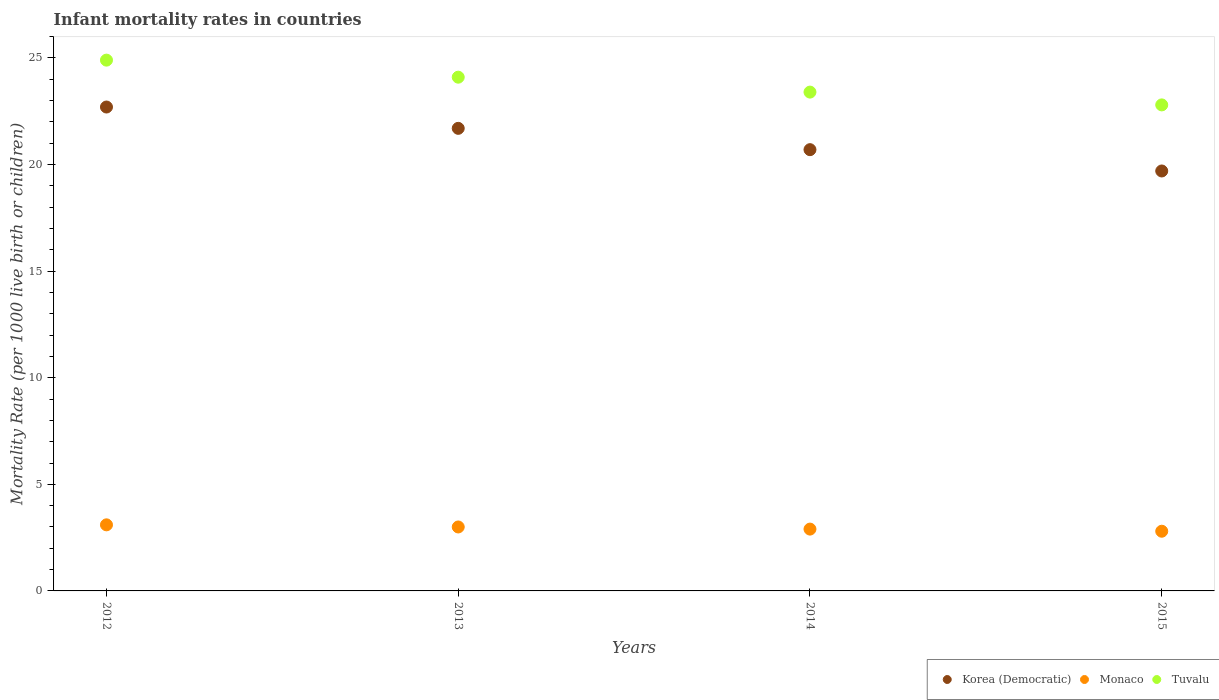Is the number of dotlines equal to the number of legend labels?
Your response must be concise. Yes. What is the infant mortality rate in Korea (Democratic) in 2014?
Your answer should be compact. 20.7. In which year was the infant mortality rate in Monaco maximum?
Your response must be concise. 2012. In which year was the infant mortality rate in Monaco minimum?
Your answer should be very brief. 2015. What is the total infant mortality rate in Monaco in the graph?
Keep it short and to the point. 11.8. What is the difference between the infant mortality rate in Monaco in 2014 and the infant mortality rate in Tuvalu in 2012?
Give a very brief answer. -22. What is the average infant mortality rate in Tuvalu per year?
Your answer should be very brief. 23.8. In the year 2015, what is the difference between the infant mortality rate in Monaco and infant mortality rate in Korea (Democratic)?
Your answer should be compact. -16.9. In how many years, is the infant mortality rate in Monaco greater than 10?
Your answer should be compact. 0. What is the ratio of the infant mortality rate in Monaco in 2013 to that in 2014?
Provide a succinct answer. 1.03. Is the infant mortality rate in Tuvalu in 2012 less than that in 2015?
Ensure brevity in your answer.  No. What is the difference between the highest and the second highest infant mortality rate in Tuvalu?
Your response must be concise. 0.8. What is the difference between the highest and the lowest infant mortality rate in Monaco?
Make the answer very short. 0.3. In how many years, is the infant mortality rate in Tuvalu greater than the average infant mortality rate in Tuvalu taken over all years?
Offer a very short reply. 2. Is the infant mortality rate in Monaco strictly greater than the infant mortality rate in Korea (Democratic) over the years?
Ensure brevity in your answer.  No. How many dotlines are there?
Keep it short and to the point. 3. Are the values on the major ticks of Y-axis written in scientific E-notation?
Offer a terse response. No. Does the graph contain any zero values?
Keep it short and to the point. No. How many legend labels are there?
Your response must be concise. 3. What is the title of the graph?
Your answer should be very brief. Infant mortality rates in countries. Does "Cote d'Ivoire" appear as one of the legend labels in the graph?
Keep it short and to the point. No. What is the label or title of the Y-axis?
Make the answer very short. Mortality Rate (per 1000 live birth or children). What is the Mortality Rate (per 1000 live birth or children) of Korea (Democratic) in 2012?
Provide a succinct answer. 22.7. What is the Mortality Rate (per 1000 live birth or children) of Monaco in 2012?
Offer a terse response. 3.1. What is the Mortality Rate (per 1000 live birth or children) in Tuvalu in 2012?
Offer a terse response. 24.9. What is the Mortality Rate (per 1000 live birth or children) in Korea (Democratic) in 2013?
Provide a succinct answer. 21.7. What is the Mortality Rate (per 1000 live birth or children) in Tuvalu in 2013?
Ensure brevity in your answer.  24.1. What is the Mortality Rate (per 1000 live birth or children) of Korea (Democratic) in 2014?
Provide a succinct answer. 20.7. What is the Mortality Rate (per 1000 live birth or children) in Tuvalu in 2014?
Your response must be concise. 23.4. What is the Mortality Rate (per 1000 live birth or children) of Korea (Democratic) in 2015?
Your answer should be compact. 19.7. What is the Mortality Rate (per 1000 live birth or children) of Monaco in 2015?
Make the answer very short. 2.8. What is the Mortality Rate (per 1000 live birth or children) of Tuvalu in 2015?
Your answer should be compact. 22.8. Across all years, what is the maximum Mortality Rate (per 1000 live birth or children) of Korea (Democratic)?
Provide a short and direct response. 22.7. Across all years, what is the maximum Mortality Rate (per 1000 live birth or children) in Monaco?
Provide a short and direct response. 3.1. Across all years, what is the maximum Mortality Rate (per 1000 live birth or children) of Tuvalu?
Provide a succinct answer. 24.9. Across all years, what is the minimum Mortality Rate (per 1000 live birth or children) of Tuvalu?
Give a very brief answer. 22.8. What is the total Mortality Rate (per 1000 live birth or children) in Korea (Democratic) in the graph?
Provide a succinct answer. 84.8. What is the total Mortality Rate (per 1000 live birth or children) of Tuvalu in the graph?
Offer a terse response. 95.2. What is the difference between the Mortality Rate (per 1000 live birth or children) in Korea (Democratic) in 2012 and that in 2013?
Give a very brief answer. 1. What is the difference between the Mortality Rate (per 1000 live birth or children) in Monaco in 2012 and that in 2013?
Ensure brevity in your answer.  0.1. What is the difference between the Mortality Rate (per 1000 live birth or children) in Korea (Democratic) in 2012 and that in 2014?
Give a very brief answer. 2. What is the difference between the Mortality Rate (per 1000 live birth or children) in Tuvalu in 2012 and that in 2014?
Keep it short and to the point. 1.5. What is the difference between the Mortality Rate (per 1000 live birth or children) in Monaco in 2012 and that in 2015?
Ensure brevity in your answer.  0.3. What is the difference between the Mortality Rate (per 1000 live birth or children) in Korea (Democratic) in 2013 and that in 2014?
Your answer should be very brief. 1. What is the difference between the Mortality Rate (per 1000 live birth or children) in Tuvalu in 2013 and that in 2014?
Keep it short and to the point. 0.7. What is the difference between the Mortality Rate (per 1000 live birth or children) of Korea (Democratic) in 2014 and that in 2015?
Ensure brevity in your answer.  1. What is the difference between the Mortality Rate (per 1000 live birth or children) in Monaco in 2014 and that in 2015?
Your answer should be very brief. 0.1. What is the difference between the Mortality Rate (per 1000 live birth or children) in Korea (Democratic) in 2012 and the Mortality Rate (per 1000 live birth or children) in Monaco in 2013?
Offer a terse response. 19.7. What is the difference between the Mortality Rate (per 1000 live birth or children) of Monaco in 2012 and the Mortality Rate (per 1000 live birth or children) of Tuvalu in 2013?
Give a very brief answer. -21. What is the difference between the Mortality Rate (per 1000 live birth or children) of Korea (Democratic) in 2012 and the Mortality Rate (per 1000 live birth or children) of Monaco in 2014?
Offer a very short reply. 19.8. What is the difference between the Mortality Rate (per 1000 live birth or children) in Korea (Democratic) in 2012 and the Mortality Rate (per 1000 live birth or children) in Tuvalu in 2014?
Provide a succinct answer. -0.7. What is the difference between the Mortality Rate (per 1000 live birth or children) of Monaco in 2012 and the Mortality Rate (per 1000 live birth or children) of Tuvalu in 2014?
Provide a short and direct response. -20.3. What is the difference between the Mortality Rate (per 1000 live birth or children) of Korea (Democratic) in 2012 and the Mortality Rate (per 1000 live birth or children) of Monaco in 2015?
Provide a short and direct response. 19.9. What is the difference between the Mortality Rate (per 1000 live birth or children) of Monaco in 2012 and the Mortality Rate (per 1000 live birth or children) of Tuvalu in 2015?
Your answer should be compact. -19.7. What is the difference between the Mortality Rate (per 1000 live birth or children) in Monaco in 2013 and the Mortality Rate (per 1000 live birth or children) in Tuvalu in 2014?
Ensure brevity in your answer.  -20.4. What is the difference between the Mortality Rate (per 1000 live birth or children) of Korea (Democratic) in 2013 and the Mortality Rate (per 1000 live birth or children) of Tuvalu in 2015?
Your response must be concise. -1.1. What is the difference between the Mortality Rate (per 1000 live birth or children) of Monaco in 2013 and the Mortality Rate (per 1000 live birth or children) of Tuvalu in 2015?
Your answer should be compact. -19.8. What is the difference between the Mortality Rate (per 1000 live birth or children) in Korea (Democratic) in 2014 and the Mortality Rate (per 1000 live birth or children) in Monaco in 2015?
Make the answer very short. 17.9. What is the difference between the Mortality Rate (per 1000 live birth or children) in Korea (Democratic) in 2014 and the Mortality Rate (per 1000 live birth or children) in Tuvalu in 2015?
Keep it short and to the point. -2.1. What is the difference between the Mortality Rate (per 1000 live birth or children) of Monaco in 2014 and the Mortality Rate (per 1000 live birth or children) of Tuvalu in 2015?
Your answer should be very brief. -19.9. What is the average Mortality Rate (per 1000 live birth or children) in Korea (Democratic) per year?
Provide a succinct answer. 21.2. What is the average Mortality Rate (per 1000 live birth or children) in Monaco per year?
Your answer should be compact. 2.95. What is the average Mortality Rate (per 1000 live birth or children) of Tuvalu per year?
Give a very brief answer. 23.8. In the year 2012, what is the difference between the Mortality Rate (per 1000 live birth or children) in Korea (Democratic) and Mortality Rate (per 1000 live birth or children) in Monaco?
Ensure brevity in your answer.  19.6. In the year 2012, what is the difference between the Mortality Rate (per 1000 live birth or children) in Korea (Democratic) and Mortality Rate (per 1000 live birth or children) in Tuvalu?
Your answer should be compact. -2.2. In the year 2012, what is the difference between the Mortality Rate (per 1000 live birth or children) in Monaco and Mortality Rate (per 1000 live birth or children) in Tuvalu?
Your response must be concise. -21.8. In the year 2013, what is the difference between the Mortality Rate (per 1000 live birth or children) in Korea (Democratic) and Mortality Rate (per 1000 live birth or children) in Monaco?
Make the answer very short. 18.7. In the year 2013, what is the difference between the Mortality Rate (per 1000 live birth or children) of Monaco and Mortality Rate (per 1000 live birth or children) of Tuvalu?
Your answer should be compact. -21.1. In the year 2014, what is the difference between the Mortality Rate (per 1000 live birth or children) in Korea (Democratic) and Mortality Rate (per 1000 live birth or children) in Monaco?
Your answer should be compact. 17.8. In the year 2014, what is the difference between the Mortality Rate (per 1000 live birth or children) in Monaco and Mortality Rate (per 1000 live birth or children) in Tuvalu?
Make the answer very short. -20.5. In the year 2015, what is the difference between the Mortality Rate (per 1000 live birth or children) in Korea (Democratic) and Mortality Rate (per 1000 live birth or children) in Monaco?
Ensure brevity in your answer.  16.9. What is the ratio of the Mortality Rate (per 1000 live birth or children) in Korea (Democratic) in 2012 to that in 2013?
Give a very brief answer. 1.05. What is the ratio of the Mortality Rate (per 1000 live birth or children) in Tuvalu in 2012 to that in 2013?
Provide a short and direct response. 1.03. What is the ratio of the Mortality Rate (per 1000 live birth or children) of Korea (Democratic) in 2012 to that in 2014?
Your response must be concise. 1.1. What is the ratio of the Mortality Rate (per 1000 live birth or children) of Monaco in 2012 to that in 2014?
Your answer should be very brief. 1.07. What is the ratio of the Mortality Rate (per 1000 live birth or children) of Tuvalu in 2012 to that in 2014?
Your response must be concise. 1.06. What is the ratio of the Mortality Rate (per 1000 live birth or children) in Korea (Democratic) in 2012 to that in 2015?
Offer a very short reply. 1.15. What is the ratio of the Mortality Rate (per 1000 live birth or children) of Monaco in 2012 to that in 2015?
Offer a very short reply. 1.11. What is the ratio of the Mortality Rate (per 1000 live birth or children) of Tuvalu in 2012 to that in 2015?
Make the answer very short. 1.09. What is the ratio of the Mortality Rate (per 1000 live birth or children) of Korea (Democratic) in 2013 to that in 2014?
Offer a terse response. 1.05. What is the ratio of the Mortality Rate (per 1000 live birth or children) in Monaco in 2013 to that in 2014?
Your answer should be very brief. 1.03. What is the ratio of the Mortality Rate (per 1000 live birth or children) in Tuvalu in 2013 to that in 2014?
Ensure brevity in your answer.  1.03. What is the ratio of the Mortality Rate (per 1000 live birth or children) in Korea (Democratic) in 2013 to that in 2015?
Make the answer very short. 1.1. What is the ratio of the Mortality Rate (per 1000 live birth or children) of Monaco in 2013 to that in 2015?
Provide a succinct answer. 1.07. What is the ratio of the Mortality Rate (per 1000 live birth or children) in Tuvalu in 2013 to that in 2015?
Ensure brevity in your answer.  1.06. What is the ratio of the Mortality Rate (per 1000 live birth or children) in Korea (Democratic) in 2014 to that in 2015?
Offer a very short reply. 1.05. What is the ratio of the Mortality Rate (per 1000 live birth or children) in Monaco in 2014 to that in 2015?
Provide a short and direct response. 1.04. What is the ratio of the Mortality Rate (per 1000 live birth or children) in Tuvalu in 2014 to that in 2015?
Provide a succinct answer. 1.03. What is the difference between the highest and the lowest Mortality Rate (per 1000 live birth or children) of Monaco?
Keep it short and to the point. 0.3. 